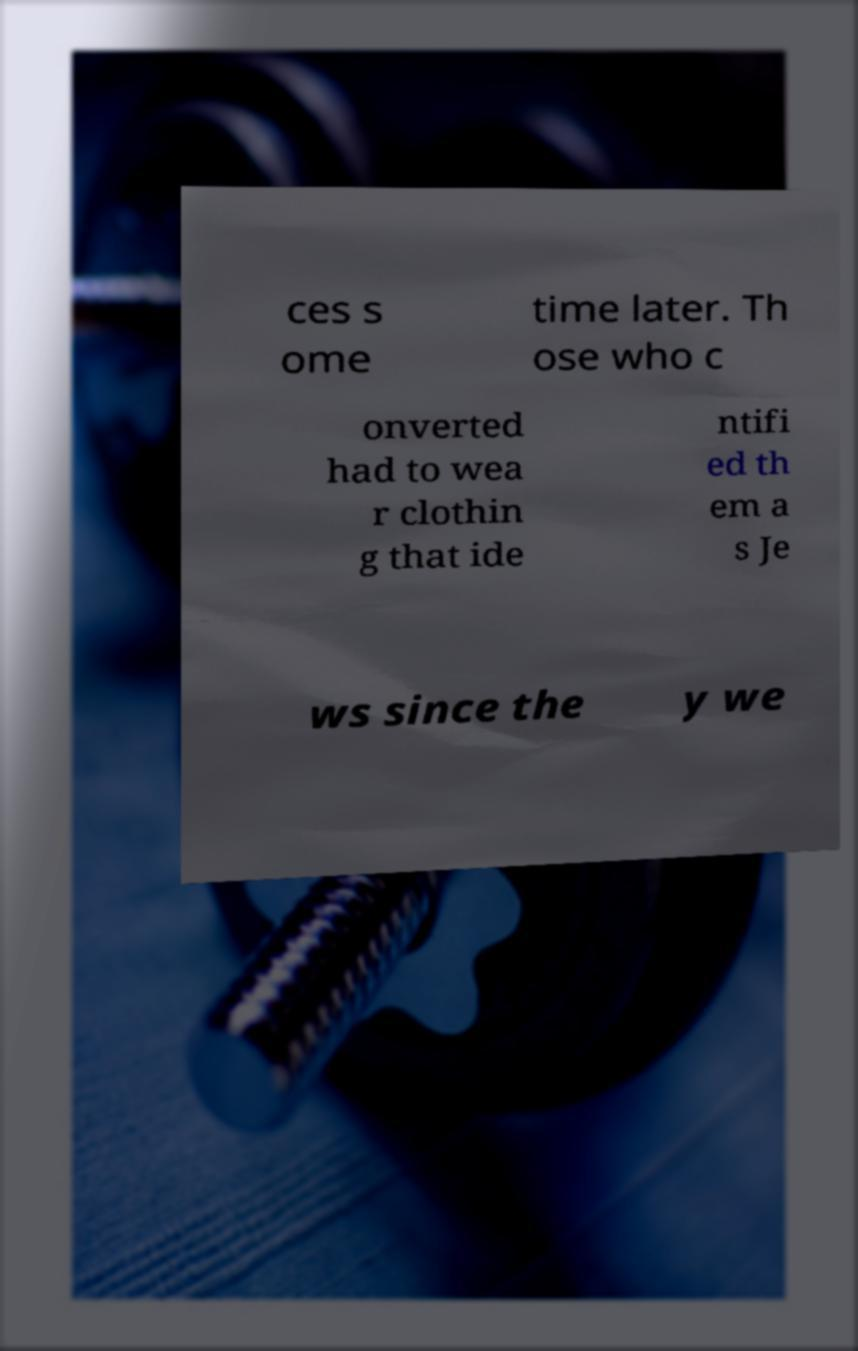Please read and relay the text visible in this image. What does it say? ces s ome time later. Th ose who c onverted had to wea r clothin g that ide ntifi ed th em a s Je ws since the y we 